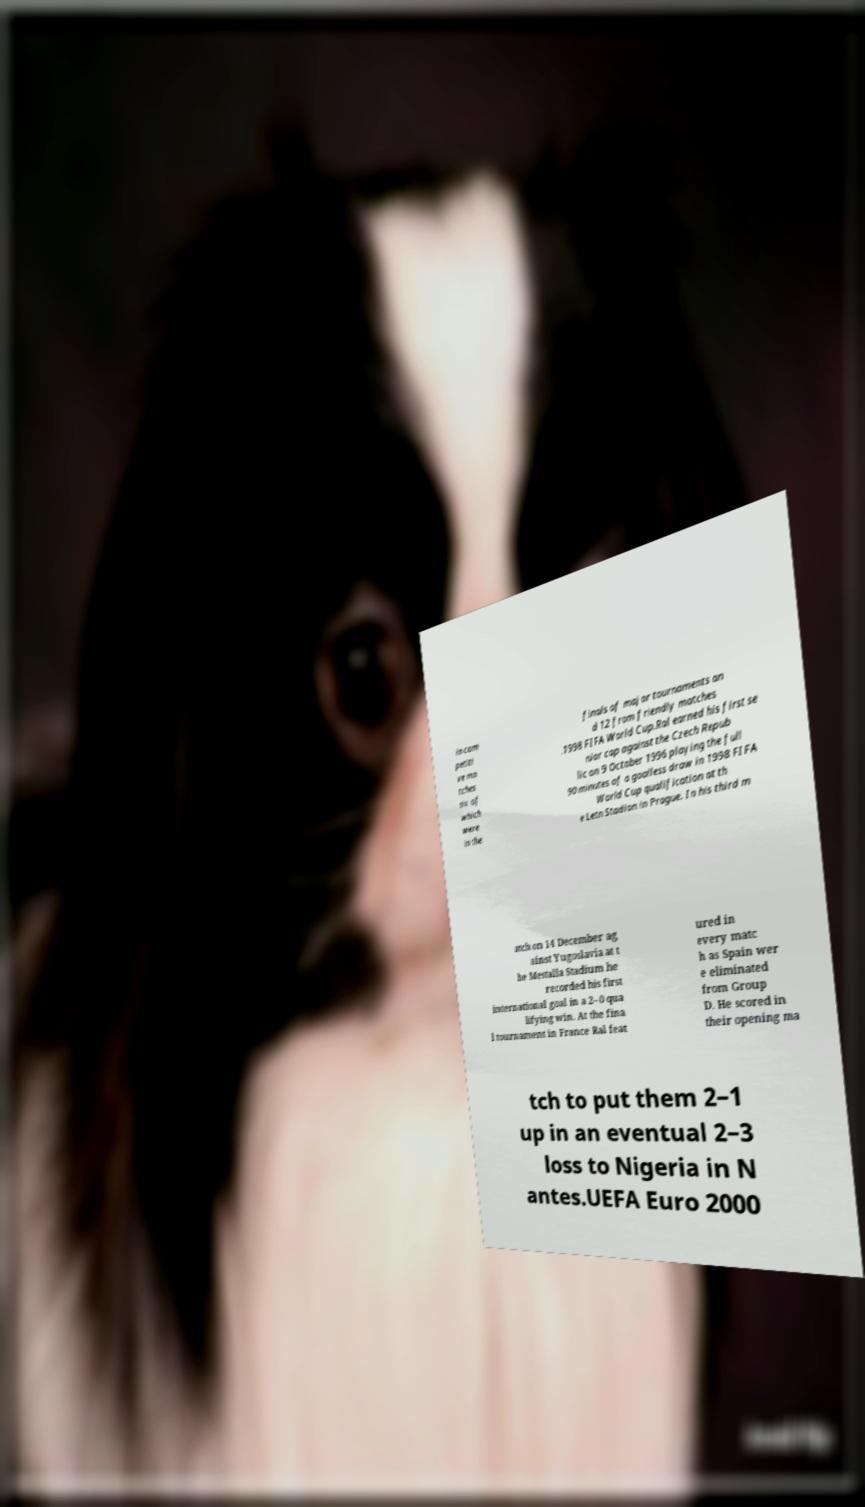Please identify and transcribe the text found in this image. in com petiti ve ma tches six of which were in the finals of major tournaments an d 12 from friendly matches .1998 FIFA World Cup.Ral earned his first se nior cap against the Czech Repub lic on 9 October 1996 playing the full 90 minutes of a goalless draw in 1998 FIFA World Cup qualification at th e Letn Stadion in Prague. In his third m atch on 14 December ag ainst Yugoslavia at t he Mestalla Stadium he recorded his first international goal in a 2–0 qua lifying win. At the fina l tournament in France Ral feat ured in every matc h as Spain wer e eliminated from Group D. He scored in their opening ma tch to put them 2–1 up in an eventual 2–3 loss to Nigeria in N antes.UEFA Euro 2000 